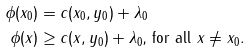Convert formula to latex. <formula><loc_0><loc_0><loc_500><loc_500>\phi ( x _ { 0 } ) & = c ( x _ { 0 } , y _ { 0 } ) + \lambda _ { 0 } \\ \phi ( x ) & \geq c ( x , y _ { 0 } ) + \lambda _ { 0 } \text {, for all } x \neq x _ { 0 } .</formula> 